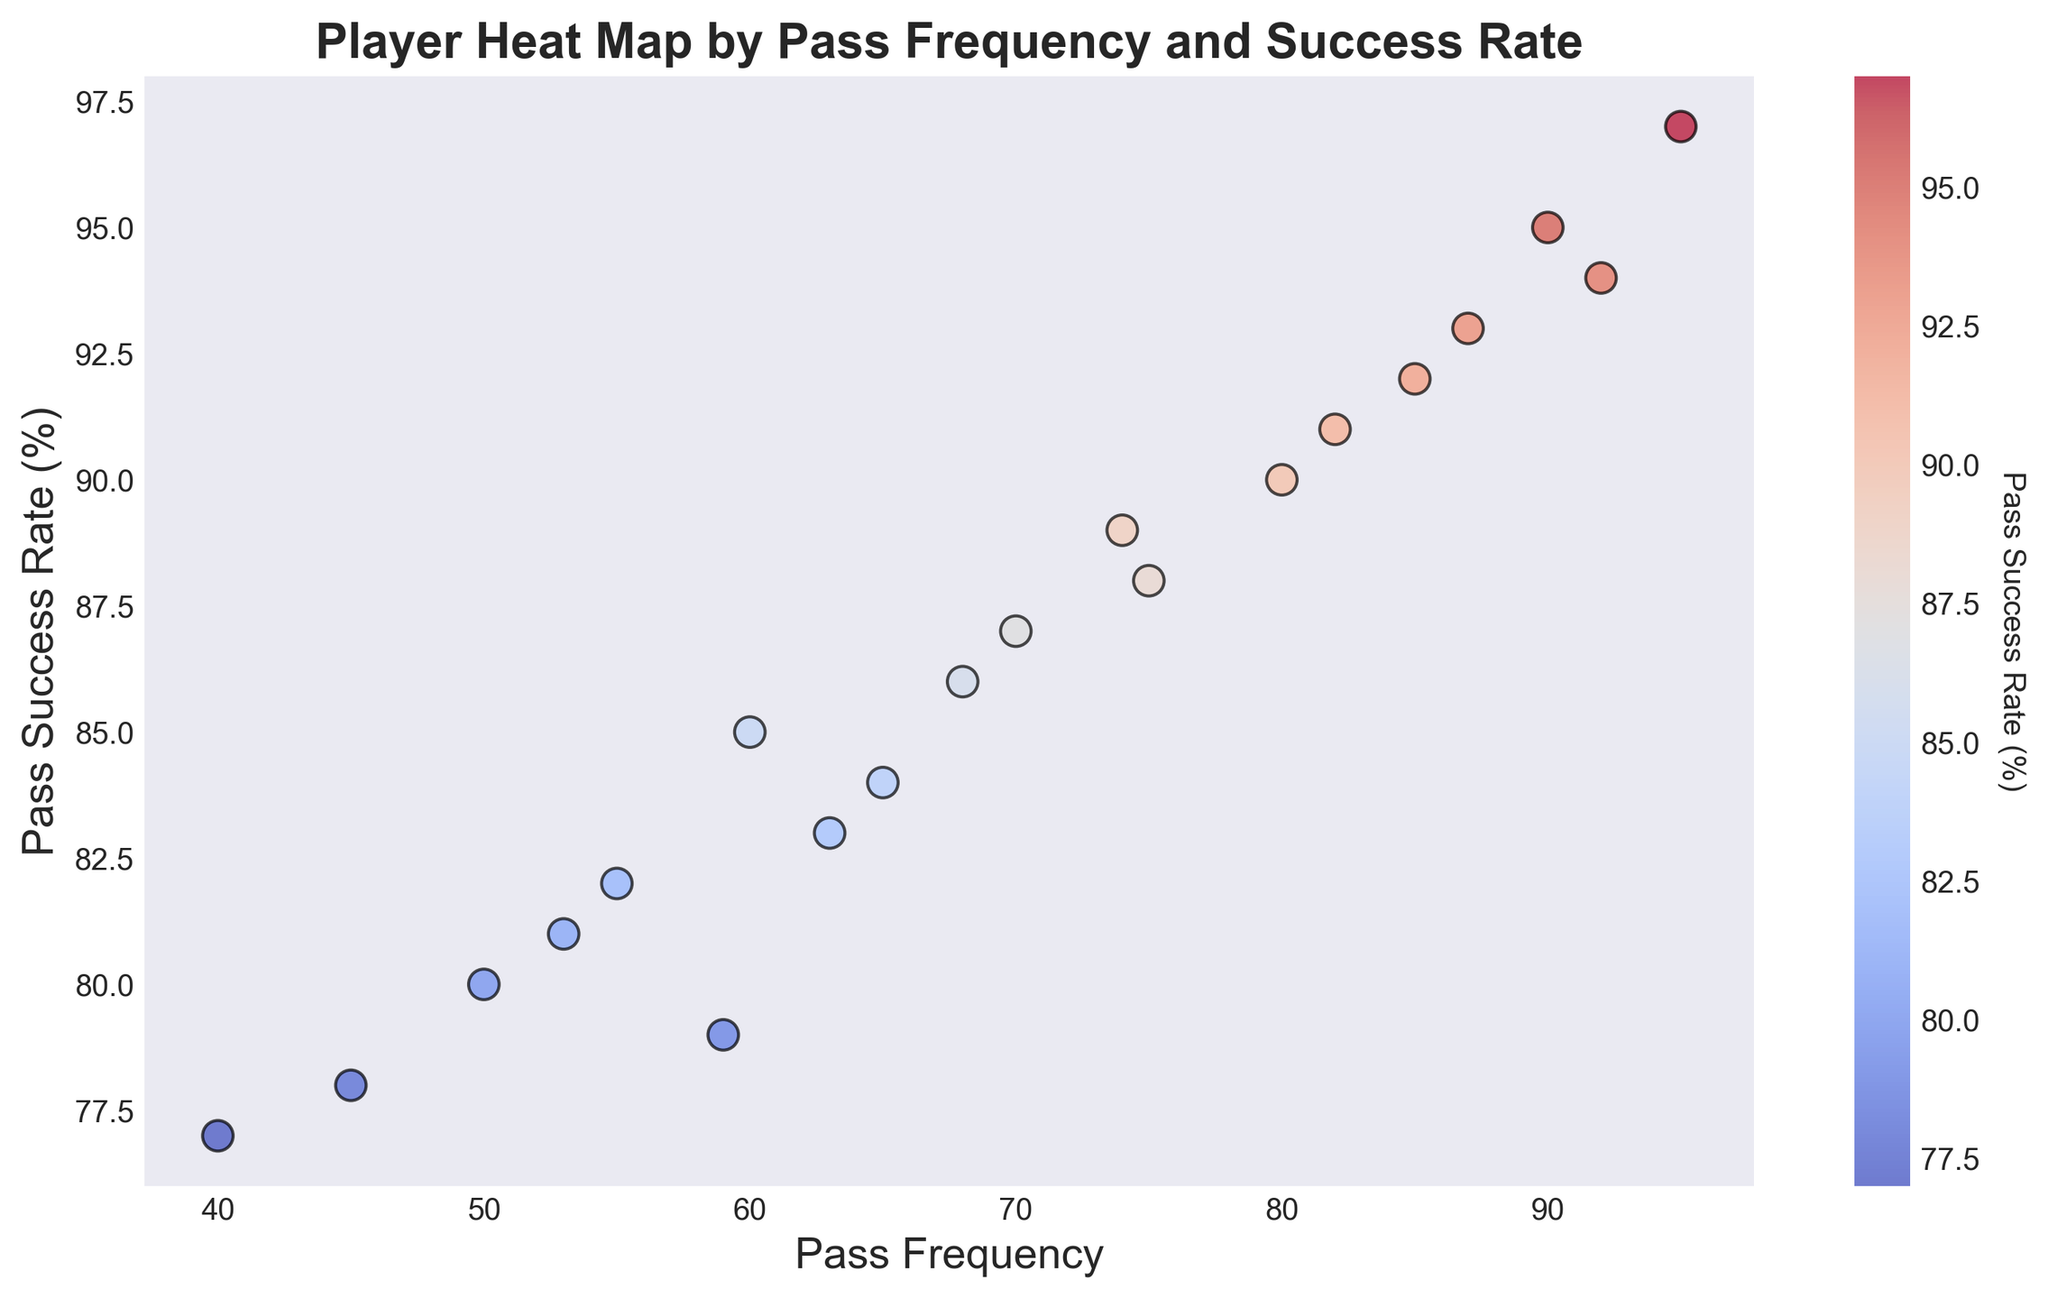Which player has the highest pass frequency? The figure shows various players with their respective pass frequencies and success rates. Look for the highest value on the x-axis (pass frequency). Player 11 has the highest pass frequency at 95.
Answer: Player 11 Which two players have the closest pass frequencies? The figure plots pass frequencies on the x-axis. By visually comparing the distances, players 16 and 10 have the closest pass frequencies, both around the mid-50s.
Answer: Players 16 and 10 What is the average pass success rate of the top three players in pass frequency? Identify the top three players based on pass frequency from the figure: Player 11 (95), Player 9 (90), and Player 19 (92). Check their pass success rates: Player 11 (97), Player 9 (95), and Player 19 (94). Calculate the average: (97+95+94)/3 = 286/3 = 95.33
Answer: 95.33 Which player has the lowest pass success rate, and what is their pass frequency? Locate the lowest value on the y-axis (pass success rate). Player 12 has the lowest pass success rate at 77%, and their pass frequency is 40.
Answer: Player 12, pass frequency 40 Compare the pass success rates of players with a pass frequency of 85 or more. Which player has the highest success rate among them? Filter the figure to focus on players with a pass frequency of 85 or more: Player 6 (85), Player 9 (90), Player 11 (95), Player 13 (87), Player 19 (92). Check their success rates: Player 6 (92), Player 9 (95), Player 11 (97), Player 13 (93), Player 19 (94). Player 11 has the highest success rate at 97%.
Answer: Player 11 What is the difference in pass success rate between players with the highest and lowest pass frequencies? Identify the players with the highest (Player 11 with pass frequency 95) and lowest (Player 12 with pass frequency 40) pass frequencies. Compare their success rates: Player 11 (97%) and Player 12 (77%). The difference is 97 - 77 = 20.
Answer: 20 Which player has the most balanced performance, considering both pass frequency and success rate? Look for a player whose pass frequency and success rate are both high but relatively close to each other. Player 9 has a high pass frequency (90) and a success rate (95%), indicating balanced and strong performance.
Answer: Player 9 Among players with pass frequencies between 50 and 70, who has the highest pass success rate? Narrow down to players within the pass frequency range 50-70: Players 2, 5, 8, 10, and 16. Compare their success rates: Player 2 (85%), Player 5 (87%), Player 8 (84%), Player 10 (82%), Player 16 (81%). The highest is Player 5 with 87%.
Answer: Player 5 